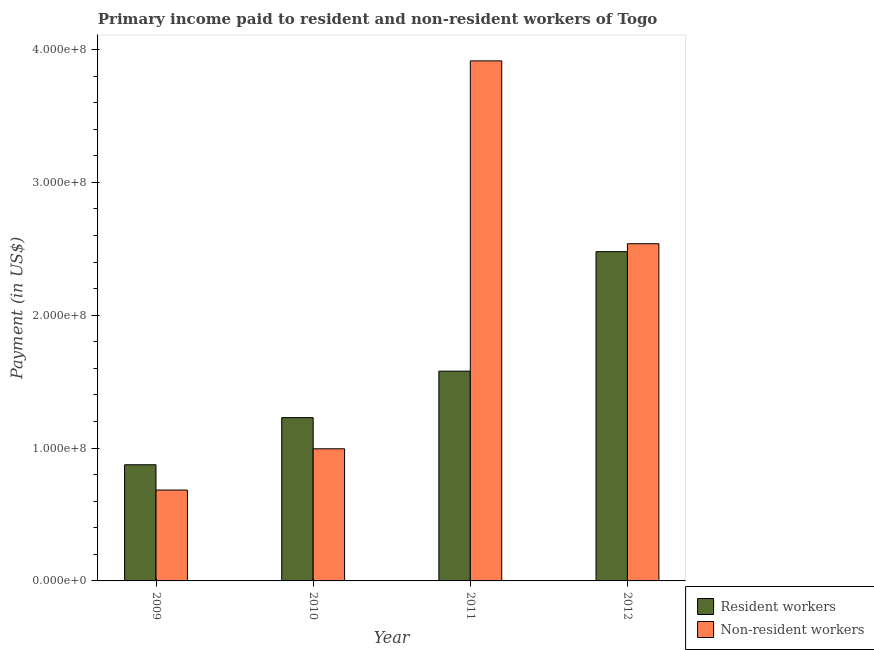How many different coloured bars are there?
Keep it short and to the point. 2. What is the label of the 1st group of bars from the left?
Your answer should be compact. 2009. What is the payment made to resident workers in 2011?
Your response must be concise. 1.58e+08. Across all years, what is the maximum payment made to resident workers?
Your answer should be very brief. 2.48e+08. Across all years, what is the minimum payment made to resident workers?
Keep it short and to the point. 8.74e+07. In which year was the payment made to non-resident workers maximum?
Your answer should be compact. 2011. In which year was the payment made to non-resident workers minimum?
Offer a very short reply. 2009. What is the total payment made to resident workers in the graph?
Offer a very short reply. 6.16e+08. What is the difference between the payment made to resident workers in 2009 and that in 2012?
Offer a terse response. -1.60e+08. What is the difference between the payment made to non-resident workers in 2010 and the payment made to resident workers in 2009?
Your answer should be compact. 3.11e+07. What is the average payment made to resident workers per year?
Ensure brevity in your answer.  1.54e+08. What is the ratio of the payment made to resident workers in 2009 to that in 2010?
Make the answer very short. 0.71. What is the difference between the highest and the second highest payment made to resident workers?
Offer a terse response. 8.99e+07. What is the difference between the highest and the lowest payment made to non-resident workers?
Give a very brief answer. 3.23e+08. In how many years, is the payment made to non-resident workers greater than the average payment made to non-resident workers taken over all years?
Offer a terse response. 2. Is the sum of the payment made to non-resident workers in 2011 and 2012 greater than the maximum payment made to resident workers across all years?
Ensure brevity in your answer.  Yes. What does the 1st bar from the left in 2009 represents?
Ensure brevity in your answer.  Resident workers. What does the 2nd bar from the right in 2009 represents?
Give a very brief answer. Resident workers. How many years are there in the graph?
Offer a very short reply. 4. Are the values on the major ticks of Y-axis written in scientific E-notation?
Provide a succinct answer. Yes. How many legend labels are there?
Give a very brief answer. 2. How are the legend labels stacked?
Offer a very short reply. Vertical. What is the title of the graph?
Keep it short and to the point. Primary income paid to resident and non-resident workers of Togo. Does "Female population" appear as one of the legend labels in the graph?
Provide a succinct answer. No. What is the label or title of the X-axis?
Keep it short and to the point. Year. What is the label or title of the Y-axis?
Offer a very short reply. Payment (in US$). What is the Payment (in US$) in Resident workers in 2009?
Keep it short and to the point. 8.74e+07. What is the Payment (in US$) of Non-resident workers in 2009?
Offer a very short reply. 6.84e+07. What is the Payment (in US$) of Resident workers in 2010?
Provide a short and direct response. 1.23e+08. What is the Payment (in US$) in Non-resident workers in 2010?
Offer a terse response. 9.95e+07. What is the Payment (in US$) in Resident workers in 2011?
Your response must be concise. 1.58e+08. What is the Payment (in US$) in Non-resident workers in 2011?
Your answer should be very brief. 3.91e+08. What is the Payment (in US$) in Resident workers in 2012?
Ensure brevity in your answer.  2.48e+08. What is the Payment (in US$) in Non-resident workers in 2012?
Your answer should be compact. 2.54e+08. Across all years, what is the maximum Payment (in US$) in Resident workers?
Offer a terse response. 2.48e+08. Across all years, what is the maximum Payment (in US$) of Non-resident workers?
Make the answer very short. 3.91e+08. Across all years, what is the minimum Payment (in US$) in Resident workers?
Ensure brevity in your answer.  8.74e+07. Across all years, what is the minimum Payment (in US$) of Non-resident workers?
Provide a short and direct response. 6.84e+07. What is the total Payment (in US$) of Resident workers in the graph?
Give a very brief answer. 6.16e+08. What is the total Payment (in US$) of Non-resident workers in the graph?
Give a very brief answer. 8.13e+08. What is the difference between the Payment (in US$) in Resident workers in 2009 and that in 2010?
Give a very brief answer. -3.55e+07. What is the difference between the Payment (in US$) in Non-resident workers in 2009 and that in 2010?
Keep it short and to the point. -3.11e+07. What is the difference between the Payment (in US$) of Resident workers in 2009 and that in 2011?
Give a very brief answer. -7.05e+07. What is the difference between the Payment (in US$) of Non-resident workers in 2009 and that in 2011?
Ensure brevity in your answer.  -3.23e+08. What is the difference between the Payment (in US$) in Resident workers in 2009 and that in 2012?
Keep it short and to the point. -1.60e+08. What is the difference between the Payment (in US$) in Non-resident workers in 2009 and that in 2012?
Ensure brevity in your answer.  -1.85e+08. What is the difference between the Payment (in US$) of Resident workers in 2010 and that in 2011?
Make the answer very short. -3.50e+07. What is the difference between the Payment (in US$) in Non-resident workers in 2010 and that in 2011?
Give a very brief answer. -2.92e+08. What is the difference between the Payment (in US$) of Resident workers in 2010 and that in 2012?
Your answer should be very brief. -1.25e+08. What is the difference between the Payment (in US$) of Non-resident workers in 2010 and that in 2012?
Make the answer very short. -1.54e+08. What is the difference between the Payment (in US$) of Resident workers in 2011 and that in 2012?
Your answer should be very brief. -8.99e+07. What is the difference between the Payment (in US$) in Non-resident workers in 2011 and that in 2012?
Your answer should be very brief. 1.38e+08. What is the difference between the Payment (in US$) of Resident workers in 2009 and the Payment (in US$) of Non-resident workers in 2010?
Offer a terse response. -1.20e+07. What is the difference between the Payment (in US$) of Resident workers in 2009 and the Payment (in US$) of Non-resident workers in 2011?
Provide a succinct answer. -3.04e+08. What is the difference between the Payment (in US$) of Resident workers in 2009 and the Payment (in US$) of Non-resident workers in 2012?
Your answer should be very brief. -1.66e+08. What is the difference between the Payment (in US$) of Resident workers in 2010 and the Payment (in US$) of Non-resident workers in 2011?
Your response must be concise. -2.69e+08. What is the difference between the Payment (in US$) of Resident workers in 2010 and the Payment (in US$) of Non-resident workers in 2012?
Offer a very short reply. -1.31e+08. What is the difference between the Payment (in US$) in Resident workers in 2011 and the Payment (in US$) in Non-resident workers in 2012?
Provide a succinct answer. -9.59e+07. What is the average Payment (in US$) of Resident workers per year?
Give a very brief answer. 1.54e+08. What is the average Payment (in US$) of Non-resident workers per year?
Offer a very short reply. 2.03e+08. In the year 2009, what is the difference between the Payment (in US$) in Resident workers and Payment (in US$) in Non-resident workers?
Your answer should be very brief. 1.90e+07. In the year 2010, what is the difference between the Payment (in US$) in Resident workers and Payment (in US$) in Non-resident workers?
Ensure brevity in your answer.  2.35e+07. In the year 2011, what is the difference between the Payment (in US$) in Resident workers and Payment (in US$) in Non-resident workers?
Your answer should be very brief. -2.34e+08. In the year 2012, what is the difference between the Payment (in US$) in Resident workers and Payment (in US$) in Non-resident workers?
Your answer should be compact. -5.98e+06. What is the ratio of the Payment (in US$) of Resident workers in 2009 to that in 2010?
Give a very brief answer. 0.71. What is the ratio of the Payment (in US$) in Non-resident workers in 2009 to that in 2010?
Ensure brevity in your answer.  0.69. What is the ratio of the Payment (in US$) of Resident workers in 2009 to that in 2011?
Make the answer very short. 0.55. What is the ratio of the Payment (in US$) in Non-resident workers in 2009 to that in 2011?
Offer a very short reply. 0.17. What is the ratio of the Payment (in US$) of Resident workers in 2009 to that in 2012?
Keep it short and to the point. 0.35. What is the ratio of the Payment (in US$) in Non-resident workers in 2009 to that in 2012?
Your response must be concise. 0.27. What is the ratio of the Payment (in US$) in Resident workers in 2010 to that in 2011?
Your answer should be compact. 0.78. What is the ratio of the Payment (in US$) of Non-resident workers in 2010 to that in 2011?
Offer a terse response. 0.25. What is the ratio of the Payment (in US$) of Resident workers in 2010 to that in 2012?
Offer a terse response. 0.5. What is the ratio of the Payment (in US$) of Non-resident workers in 2010 to that in 2012?
Offer a terse response. 0.39. What is the ratio of the Payment (in US$) in Resident workers in 2011 to that in 2012?
Your answer should be very brief. 0.64. What is the ratio of the Payment (in US$) of Non-resident workers in 2011 to that in 2012?
Offer a terse response. 1.54. What is the difference between the highest and the second highest Payment (in US$) of Resident workers?
Offer a terse response. 8.99e+07. What is the difference between the highest and the second highest Payment (in US$) of Non-resident workers?
Ensure brevity in your answer.  1.38e+08. What is the difference between the highest and the lowest Payment (in US$) of Resident workers?
Your answer should be very brief. 1.60e+08. What is the difference between the highest and the lowest Payment (in US$) of Non-resident workers?
Provide a succinct answer. 3.23e+08. 